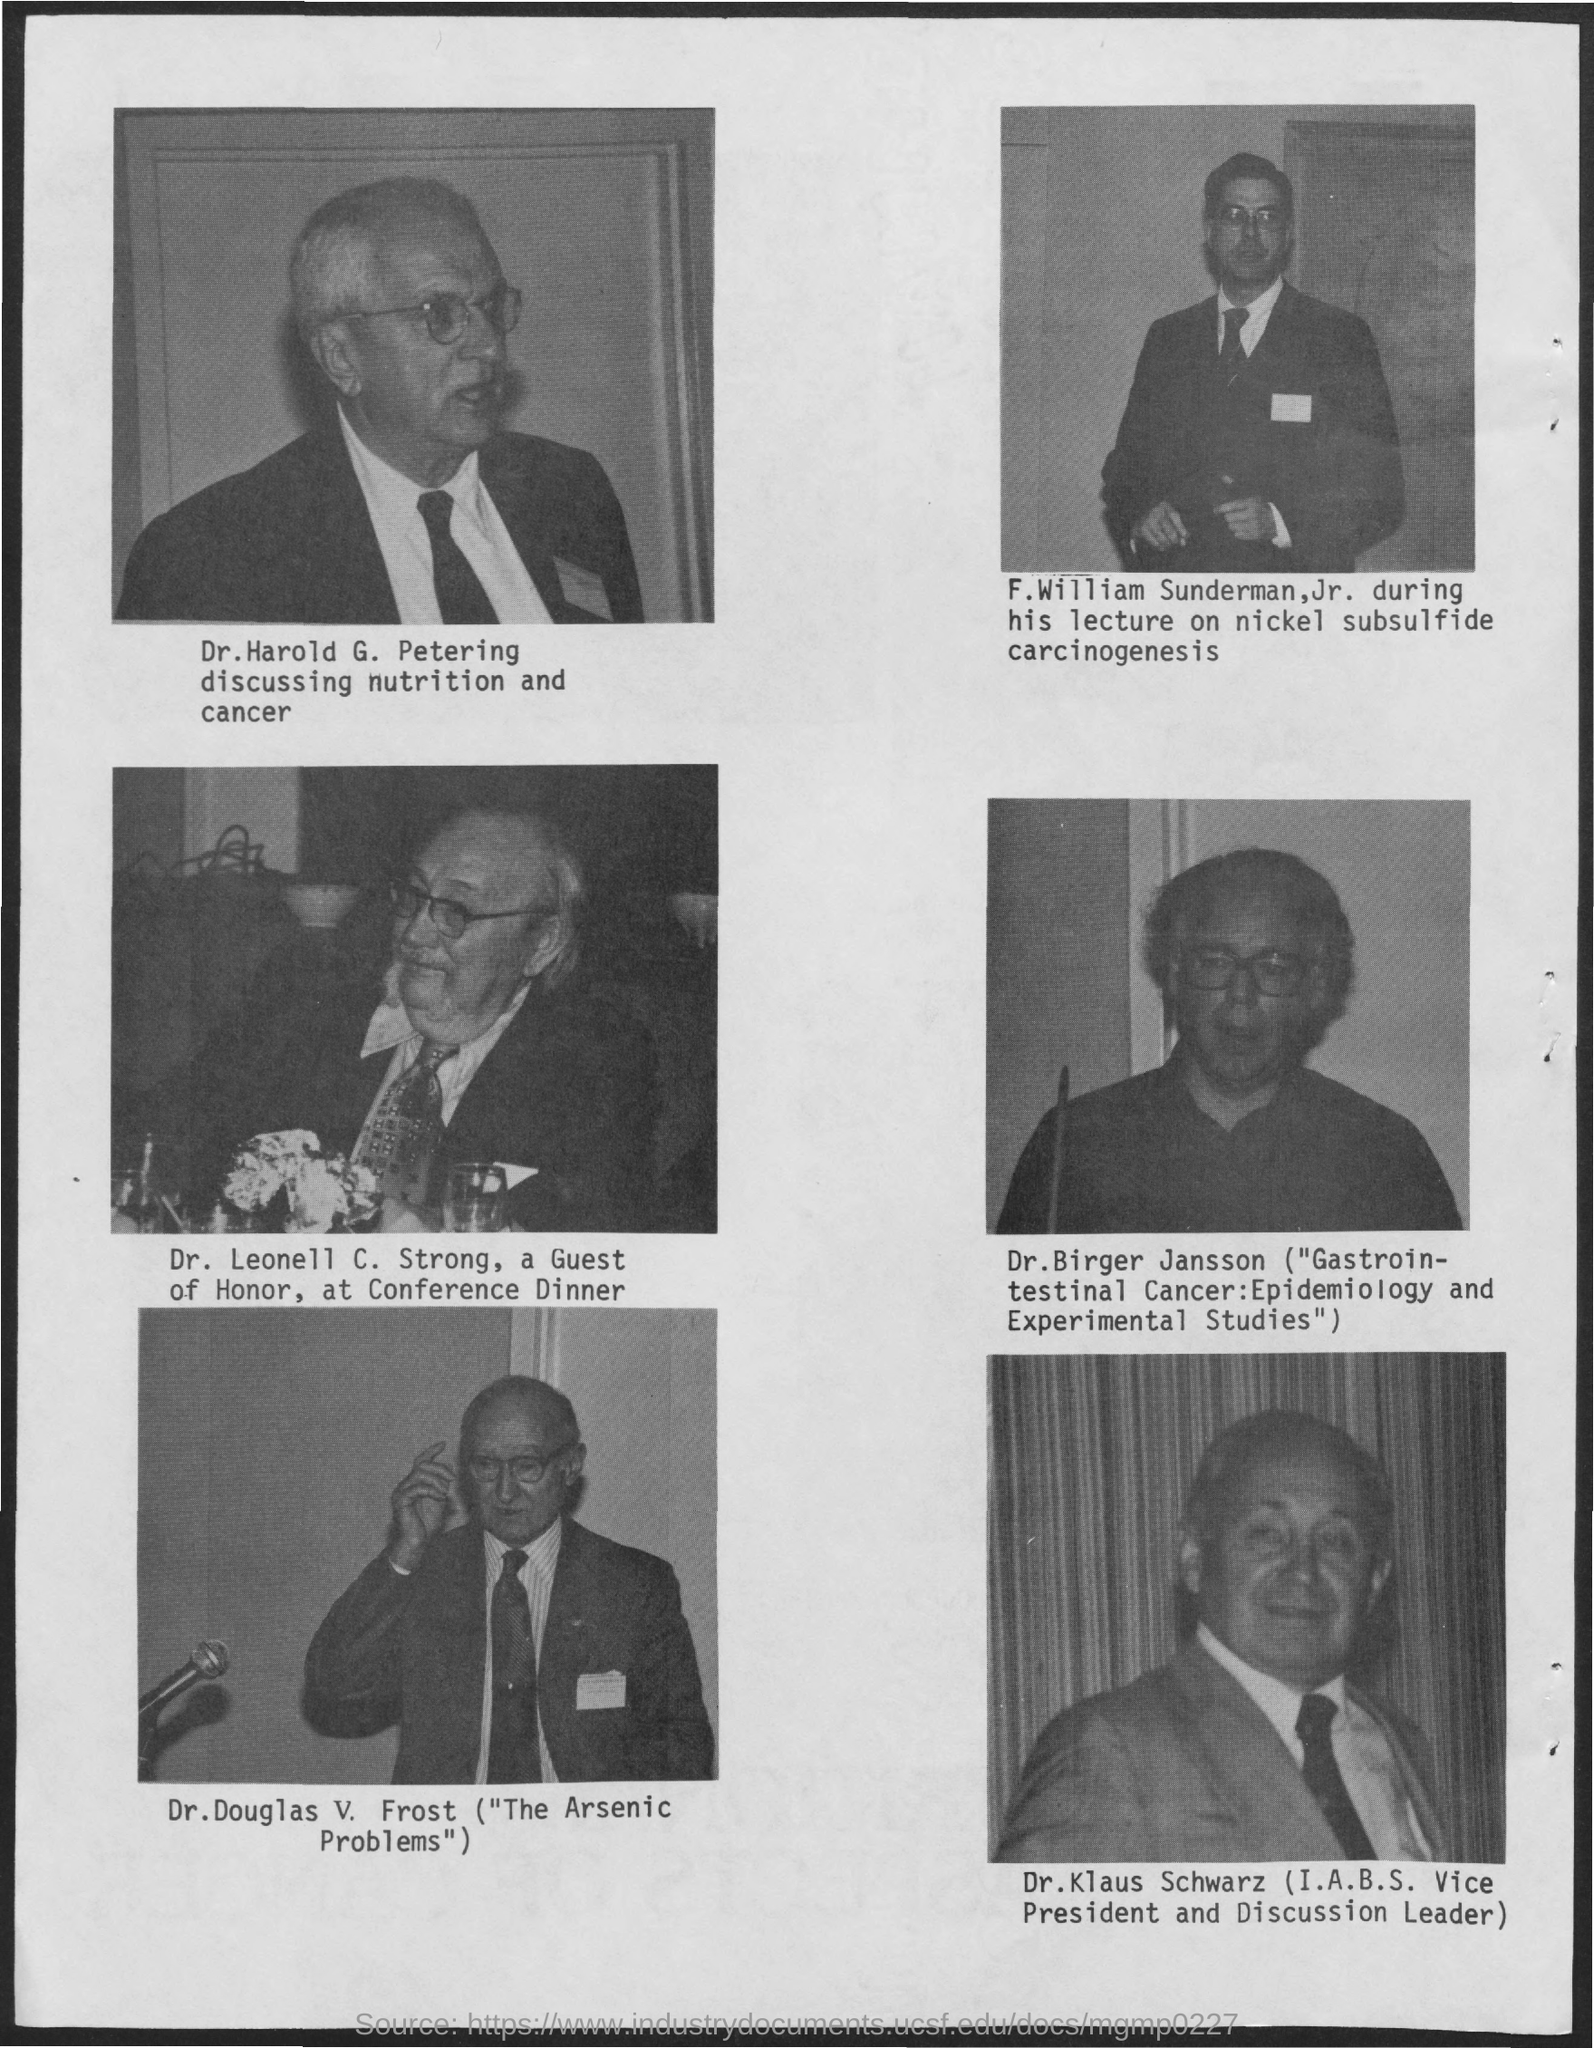Indicate a few pertinent items in this graphic. Dr. Harold G. Petering's picture is shown first. Dr. Klaus Schwarz is the Vice President of I.A.B.S. Dr. Harold G. Petering was discussing the topic of nutrition and cancer. Dr. Klaus Schwarz held the position of Vice President in the International Association of Biological Standardization. The guest of honor at the Conference Dinner was Dr. Leonell C. Strong. 